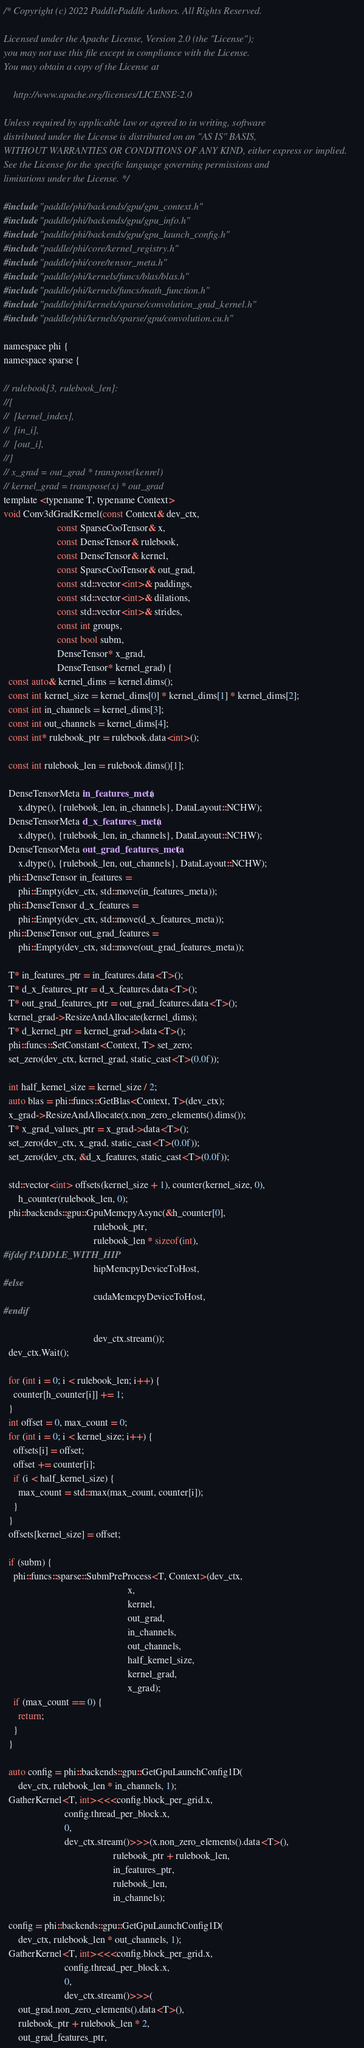Convert code to text. <code><loc_0><loc_0><loc_500><loc_500><_Cuda_>/* Copyright (c) 2022 PaddlePaddle Authors. All Rights Reserved.

Licensed under the Apache License, Version 2.0 (the "License");
you may not use this file except in compliance with the License.
You may obtain a copy of the License at

    http://www.apache.org/licenses/LICENSE-2.0

Unless required by applicable law or agreed to in writing, software
distributed under the License is distributed on an "AS IS" BASIS,
WITHOUT WARRANTIES OR CONDITIONS OF ANY KIND, either express or implied.
See the License for the specific language governing permissions and
limitations under the License. */

#include "paddle/phi/backends/gpu/gpu_context.h"
#include "paddle/phi/backends/gpu/gpu_info.h"
#include "paddle/phi/backends/gpu/gpu_launch_config.h"
#include "paddle/phi/core/kernel_registry.h"
#include "paddle/phi/core/tensor_meta.h"
#include "paddle/phi/kernels/funcs/blas/blas.h"
#include "paddle/phi/kernels/funcs/math_function.h"
#include "paddle/phi/kernels/sparse/convolution_grad_kernel.h"
#include "paddle/phi/kernels/sparse/gpu/convolution.cu.h"

namespace phi {
namespace sparse {

// rulebook[3, rulebook_len]:
//[
//  [kernel_index],
//  [in_i],
//  [out_i],
//]
// x_grad = out_grad * transpose(kenrel)
// kernel_grad = transpose(x) * out_grad
template <typename T, typename Context>
void Conv3dGradKernel(const Context& dev_ctx,
                      const SparseCooTensor& x,
                      const DenseTensor& rulebook,
                      const DenseTensor& kernel,
                      const SparseCooTensor& out_grad,
                      const std::vector<int>& paddings,
                      const std::vector<int>& dilations,
                      const std::vector<int>& strides,
                      const int groups,
                      const bool subm,
                      DenseTensor* x_grad,
                      DenseTensor* kernel_grad) {
  const auto& kernel_dims = kernel.dims();
  const int kernel_size = kernel_dims[0] * kernel_dims[1] * kernel_dims[2];
  const int in_channels = kernel_dims[3];
  const int out_channels = kernel_dims[4];
  const int* rulebook_ptr = rulebook.data<int>();

  const int rulebook_len = rulebook.dims()[1];

  DenseTensorMeta in_features_meta(
      x.dtype(), {rulebook_len, in_channels}, DataLayout::NCHW);
  DenseTensorMeta d_x_features_meta(
      x.dtype(), {rulebook_len, in_channels}, DataLayout::NCHW);
  DenseTensorMeta out_grad_features_meta(
      x.dtype(), {rulebook_len, out_channels}, DataLayout::NCHW);
  phi::DenseTensor in_features =
      phi::Empty(dev_ctx, std::move(in_features_meta));
  phi::DenseTensor d_x_features =
      phi::Empty(dev_ctx, std::move(d_x_features_meta));
  phi::DenseTensor out_grad_features =
      phi::Empty(dev_ctx, std::move(out_grad_features_meta));

  T* in_features_ptr = in_features.data<T>();
  T* d_x_features_ptr = d_x_features.data<T>();
  T* out_grad_features_ptr = out_grad_features.data<T>();
  kernel_grad->ResizeAndAllocate(kernel_dims);
  T* d_kernel_ptr = kernel_grad->data<T>();
  phi::funcs::SetConstant<Context, T> set_zero;
  set_zero(dev_ctx, kernel_grad, static_cast<T>(0.0f));

  int half_kernel_size = kernel_size / 2;
  auto blas = phi::funcs::GetBlas<Context, T>(dev_ctx);
  x_grad->ResizeAndAllocate(x.non_zero_elements().dims());
  T* x_grad_values_ptr = x_grad->data<T>();
  set_zero(dev_ctx, x_grad, static_cast<T>(0.0f));
  set_zero(dev_ctx, &d_x_features, static_cast<T>(0.0f));

  std::vector<int> offsets(kernel_size + 1), counter(kernel_size, 0),
      h_counter(rulebook_len, 0);
  phi::backends::gpu::GpuMemcpyAsync(&h_counter[0],
                                     rulebook_ptr,
                                     rulebook_len * sizeof(int),
#ifdef PADDLE_WITH_HIP
                                     hipMemcpyDeviceToHost,
#else
                                     cudaMemcpyDeviceToHost,
#endif

                                     dev_ctx.stream());
  dev_ctx.Wait();

  for (int i = 0; i < rulebook_len; i++) {
    counter[h_counter[i]] += 1;
  }
  int offset = 0, max_count = 0;
  for (int i = 0; i < kernel_size; i++) {
    offsets[i] = offset;
    offset += counter[i];
    if (i < half_kernel_size) {
      max_count = std::max(max_count, counter[i]);
    }
  }
  offsets[kernel_size] = offset;

  if (subm) {
    phi::funcs::sparse::SubmPreProcess<T, Context>(dev_ctx,
                                                   x,
                                                   kernel,
                                                   out_grad,
                                                   in_channels,
                                                   out_channels,
                                                   half_kernel_size,
                                                   kernel_grad,
                                                   x_grad);
    if (max_count == 0) {
      return;
    }
  }

  auto config = phi::backends::gpu::GetGpuLaunchConfig1D(
      dev_ctx, rulebook_len * in_channels, 1);
  GatherKernel<T, int><<<config.block_per_grid.x,
                         config.thread_per_block.x,
                         0,
                         dev_ctx.stream()>>>(x.non_zero_elements().data<T>(),
                                             rulebook_ptr + rulebook_len,
                                             in_features_ptr,
                                             rulebook_len,
                                             in_channels);

  config = phi::backends::gpu::GetGpuLaunchConfig1D(
      dev_ctx, rulebook_len * out_channels, 1);
  GatherKernel<T, int><<<config.block_per_grid.x,
                         config.thread_per_block.x,
                         0,
                         dev_ctx.stream()>>>(
      out_grad.non_zero_elements().data<T>(),
      rulebook_ptr + rulebook_len * 2,
      out_grad_features_ptr,</code> 